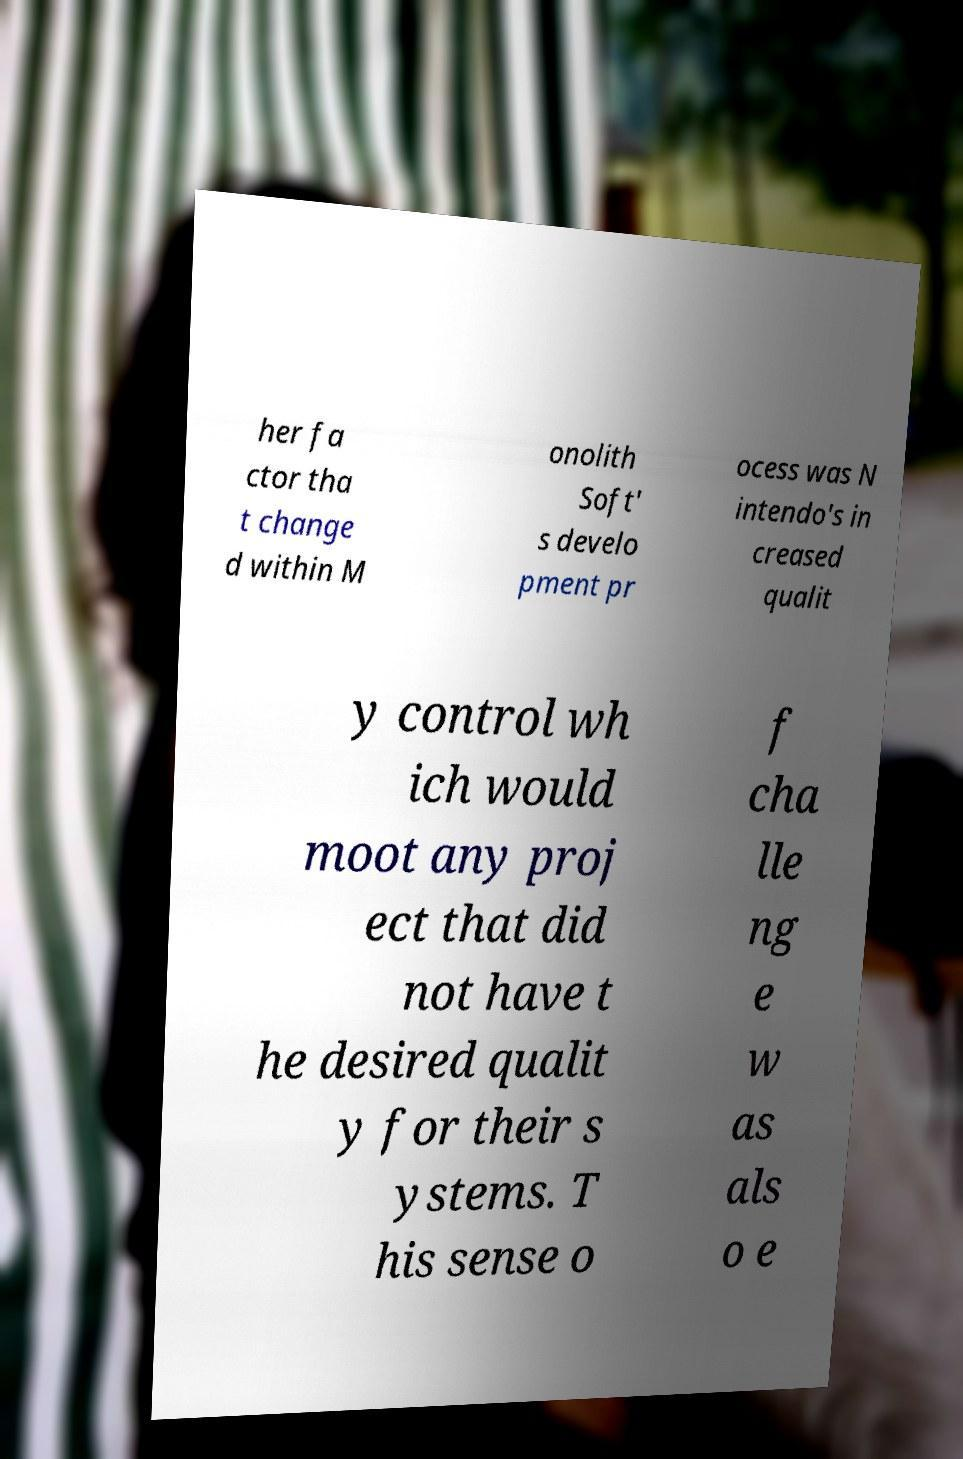Please read and relay the text visible in this image. What does it say? her fa ctor tha t change d within M onolith Soft' s develo pment pr ocess was N intendo's in creased qualit y control wh ich would moot any proj ect that did not have t he desired qualit y for their s ystems. T his sense o f cha lle ng e w as als o e 